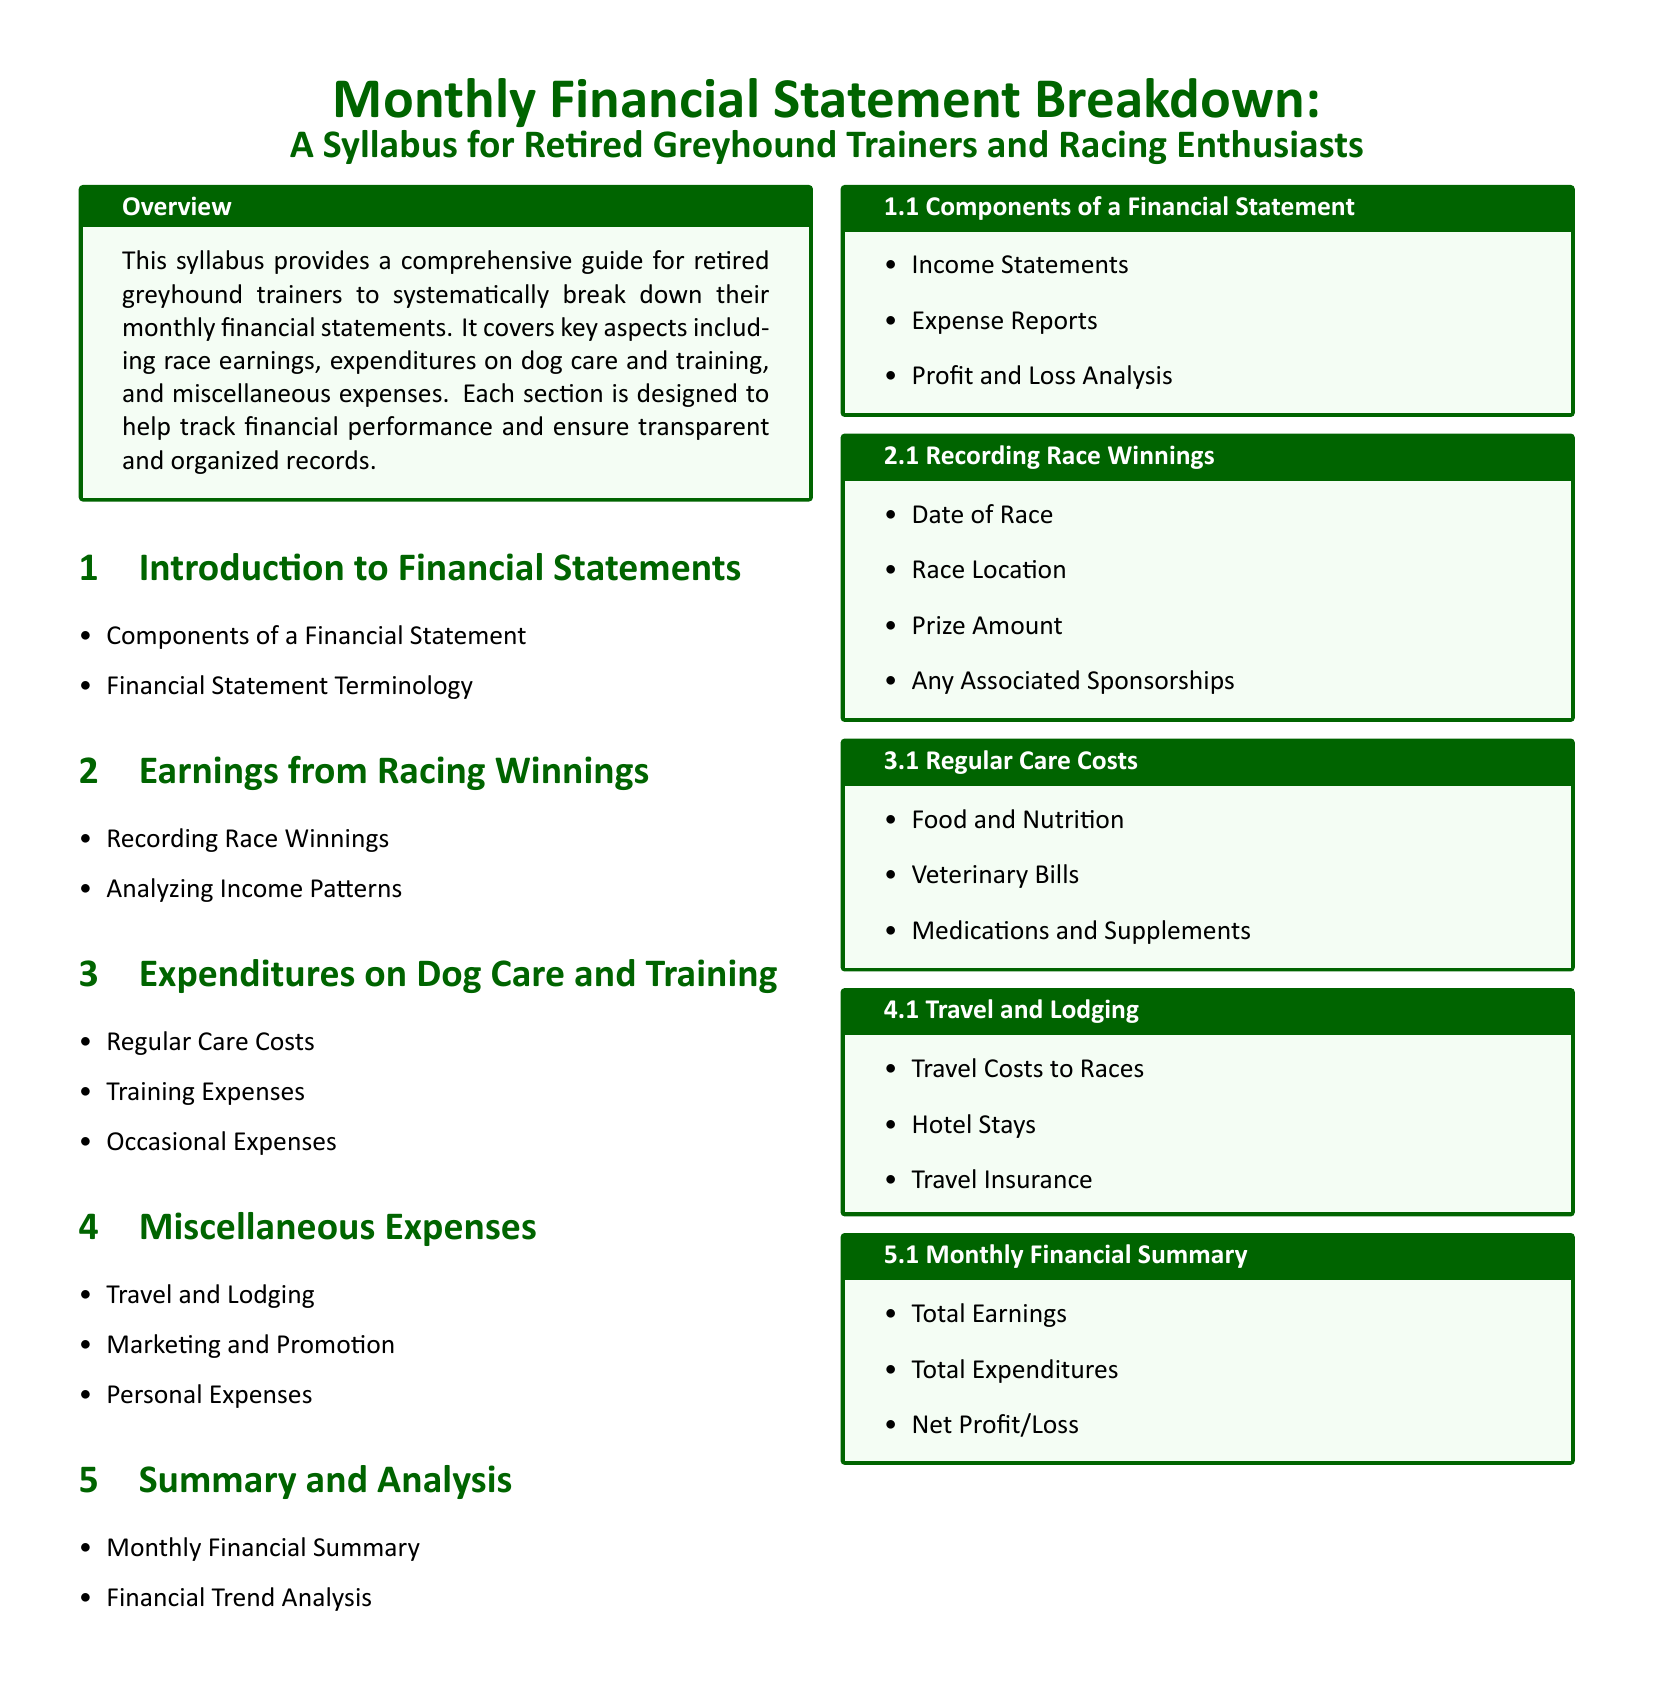What is the title of the syllabus? The title of the syllabus is prominently displayed at the top of the document, indicating the subject matter covered.
Answer: Monthly Financial Statement Breakdown What section covers earnings from racing winnings? The document explicitly lists sections; this particular information is found as a main section.
Answer: Earnings from Racing Winnings How many subsections are under Expenditures on Dog Care and Training? The subsections are listed in a bulleted format, indicating the breakdown of content underneath this main section.
Answer: Three What type of expenses are included in Miscellaneous Expenses? The subsection details the various costs that fall outside of primary expenditures related to dog care and training.
Answer: Travel and Lodging What is included in the Monthly Financial Summary? This section outlines key elements that summarize the financial performance for the month.
Answer: Total Earnings What is the primary focus of the Overview section? The Overview provides a brief description of what the syllabus aims to accomplish and the target audience.
Answer: Financial performance tracking Identify one component of a Financial Statement. This answers a question about specific content provided in the syllabus focusing on financial document components.
Answer: Income Statements Name a regular care cost mentioned in the syllabus. The document lists various costs associated with dog care under a specific section.
Answer: Food and Nutrition 